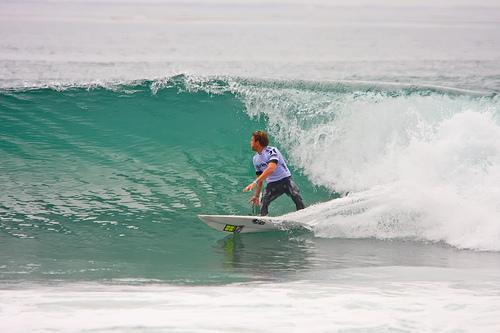How many surfboards are shown?
Give a very brief answer. 1. How many surfers are pictured?
Give a very brief answer. 1. 